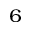<formula> <loc_0><loc_0><loc_500><loc_500>^ { 6 }</formula> 